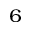<formula> <loc_0><loc_0><loc_500><loc_500>^ { 6 }</formula> 